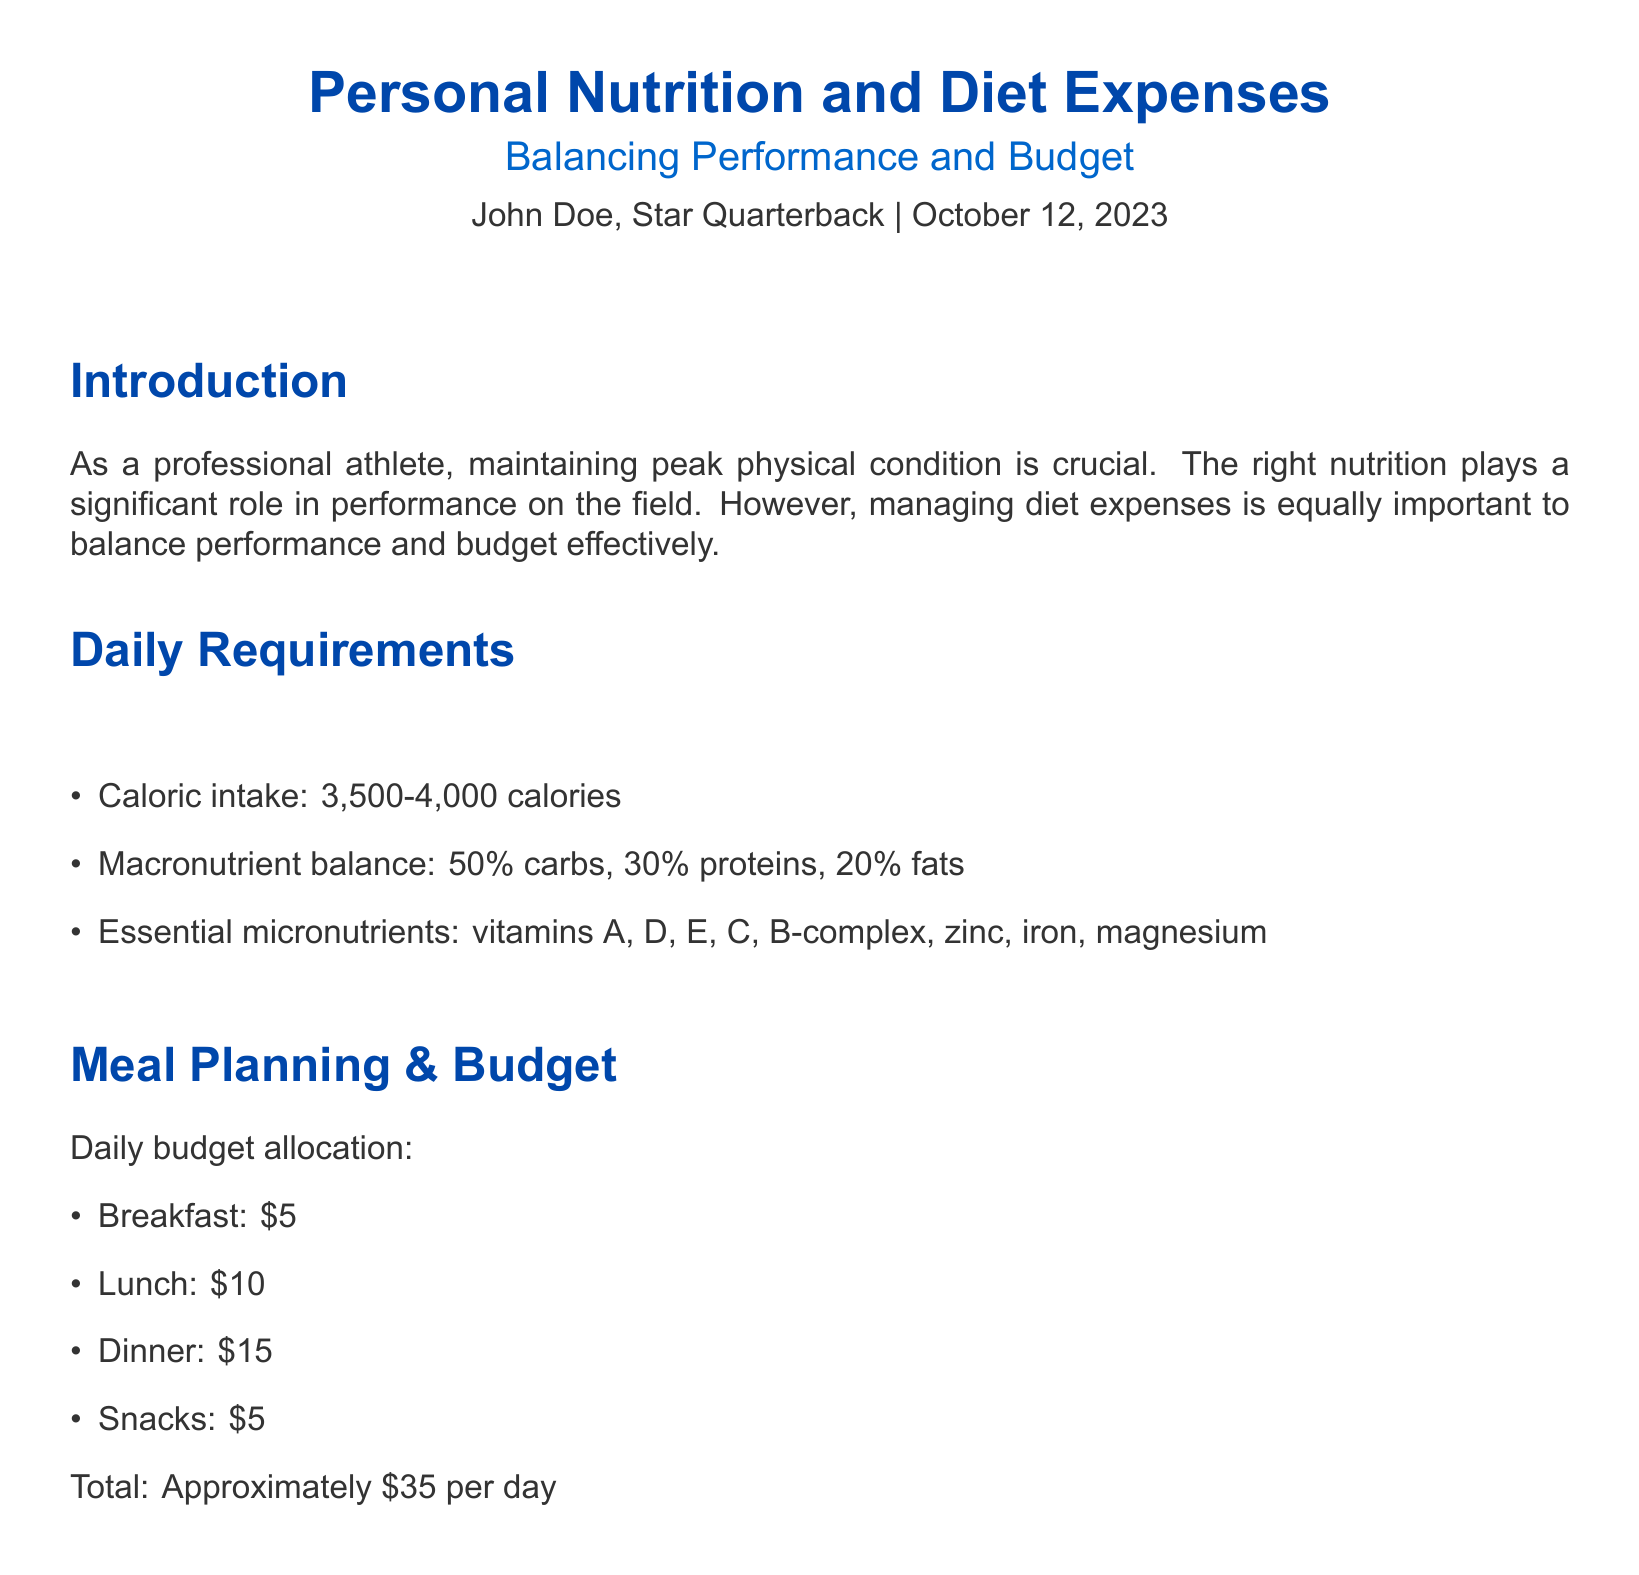What is the daily caloric intake range? The daily caloric intake range is specified as 3,500-4,000 calories in the document.
Answer: 3,500-4,000 calories What is the percentage of proteins in the macronutrient balance? The document states that the macronutrient balance consists of 30% proteins.
Answer: 30% How much is allocated for dinner in the daily budget? The document indicates a budget allocation of $15 for dinner.
Answer: $15 What is the weekly cost of chicken breast? The document lists the weekly cost of chicken breast as $24.50.
Answer: $24.50 Which supplement has the lowest weekly cost? The document shows that Omega-3 Capsules have the lowest weekly cost at $3.75.
Answer: $3.75 How many categories of nutritional expenses are listed? The document mentions four categories: Proteins, Carbohydrates, Fruits and Vegetables, and Supplements.
Answer: Four What meal has the highest budget allocation? The document states that dinner has the highest budget allocation at $15.
Answer: Dinner What strategy is emphasized for balancing performance and budget? The document emphasizes strategic meal planning to maintain performance within budget.
Answer: Strategic meal planning What is the total approximate daily budget for meals? The document calculates the total approximate daily budget for meals as $35.
Answer: $35 